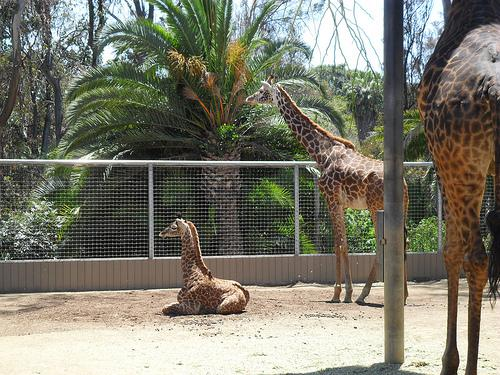Question: what is the animal shown in the picture?
Choices:
A. Cow.
B. Goat.
C. Mouse.
D. Giraffe.
Answer with the letter. Answer: D Question: where was this picture taken?
Choices:
A. Market.
B. Park.
C. Zoo.
D. Aquarium.
Answer with the letter. Answer: C Question: how many giraffes are shown in the picture?
Choices:
A. Four.
B. Three.
C. Two.
D. Seven.
Answer with the letter. Answer: B Question: what is the main color of the trees?
Choices:
A. Brown.
B. Yellow.
C. Red.
D. Green.
Answer with the letter. Answer: D Question: what direction are the giraffes looking?
Choices:
A. Left.
B. Right.
C. Above.
D. Below.
Answer with the letter. Answer: A 